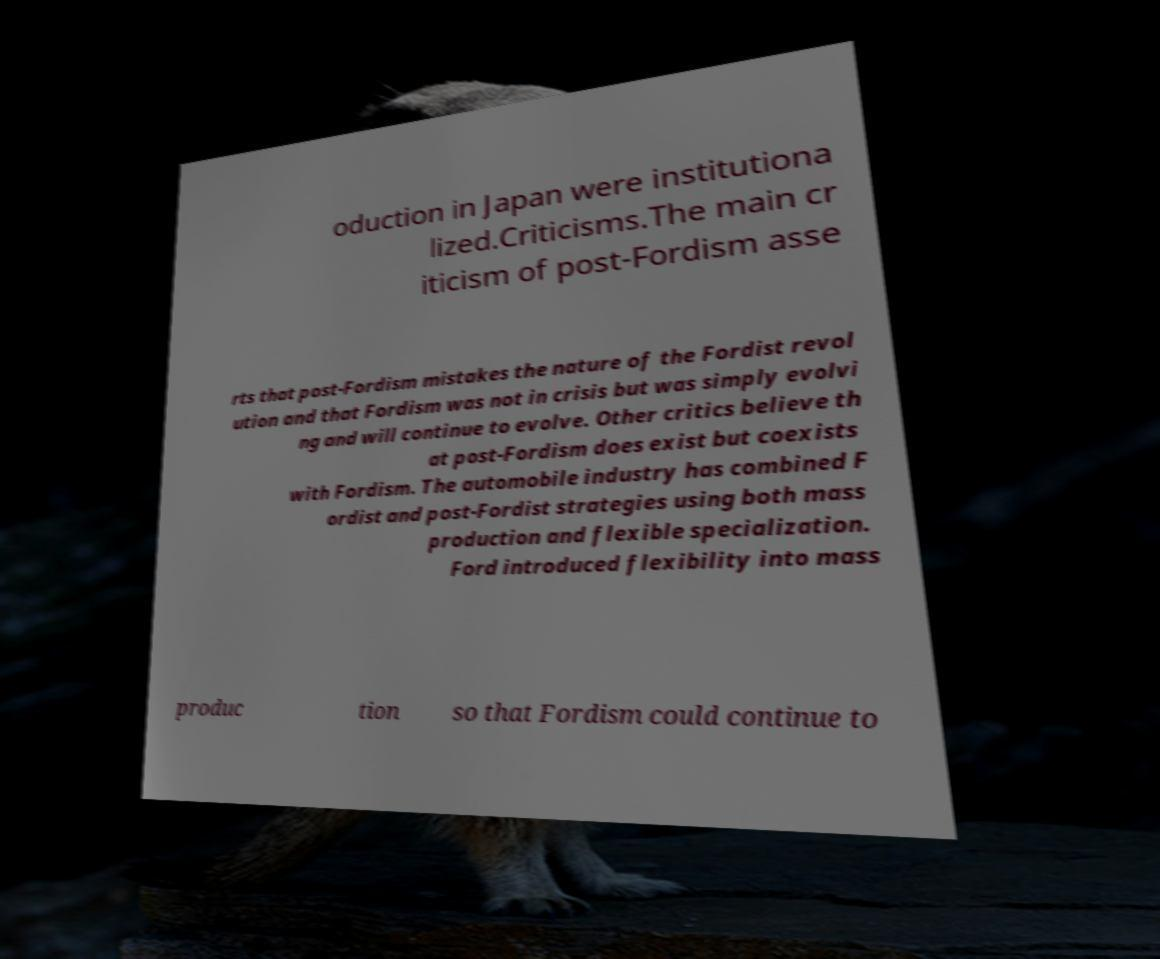Can you accurately transcribe the text from the provided image for me? oduction in Japan were institutiona lized.Criticisms.The main cr iticism of post-Fordism asse rts that post-Fordism mistakes the nature of the Fordist revol ution and that Fordism was not in crisis but was simply evolvi ng and will continue to evolve. Other critics believe th at post-Fordism does exist but coexists with Fordism. The automobile industry has combined F ordist and post-Fordist strategies using both mass production and flexible specialization. Ford introduced flexibility into mass produc tion so that Fordism could continue to 